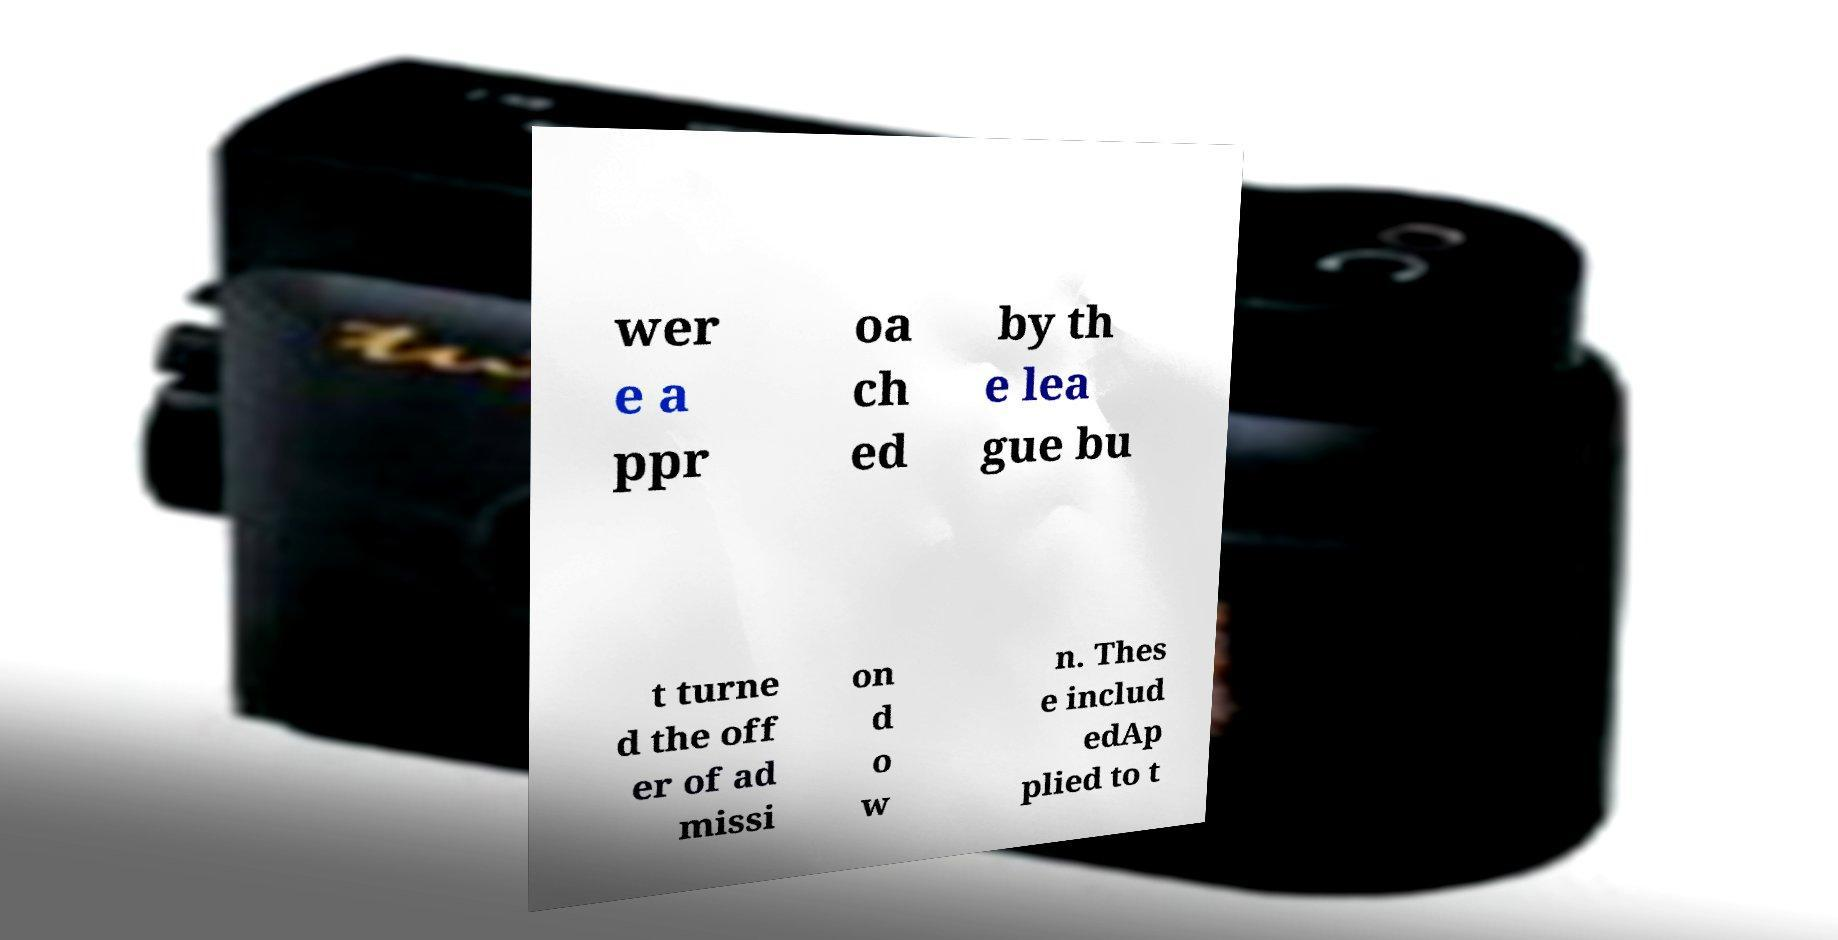I need the written content from this picture converted into text. Can you do that? wer e a ppr oa ch ed by th e lea gue bu t turne d the off er of ad missi on d o w n. Thes e includ edAp plied to t 